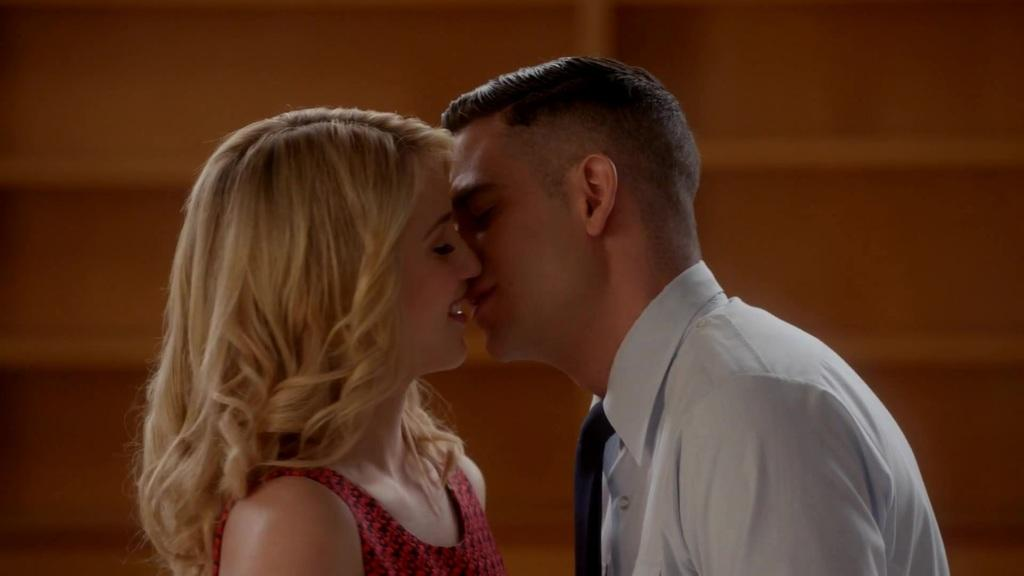How many people are in the image? There are two persons in the image. What are the two persons doing in the image? The two persons are kissing each other. What type of juice can be seen on the coast in the morning? There is no coast, morning, or juice present in the image. The image only features two persons kissing each other. 